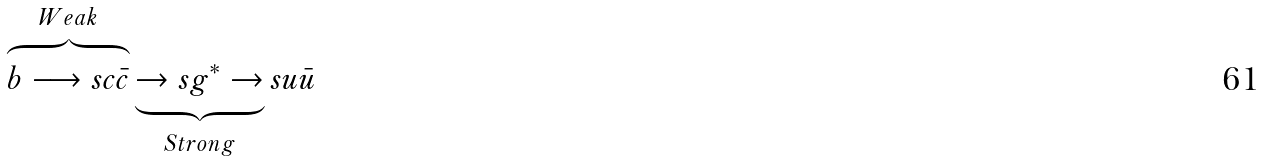<formula> <loc_0><loc_0><loc_500><loc_500>\overbrace { b \longrightarrow s c \bar { c } } ^ { W e a k } \underbrace { \to s g ^ { * } \to } _ { S t r o n g } s u \bar { u }</formula> 